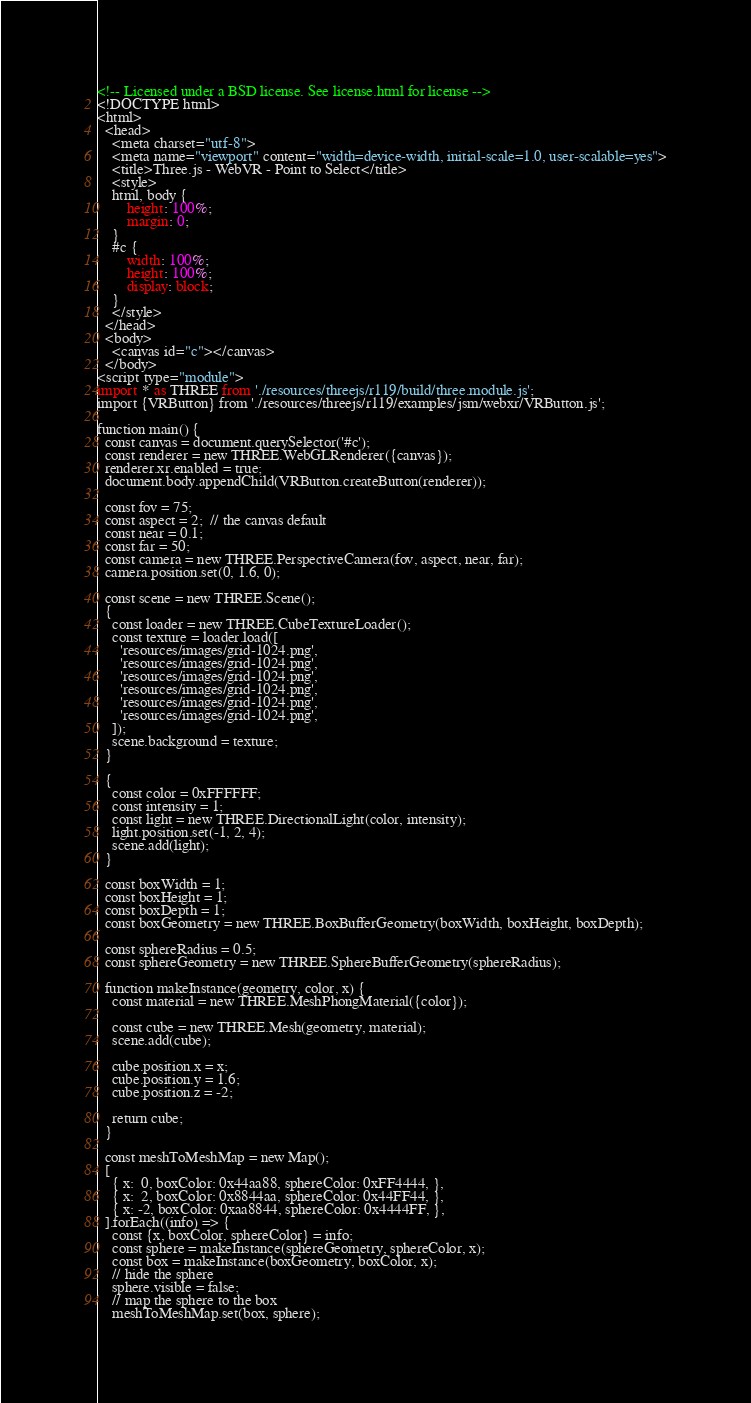<code> <loc_0><loc_0><loc_500><loc_500><_HTML_><!-- Licensed under a BSD license. See license.html for license -->
<!DOCTYPE html>
<html>
  <head>
    <meta charset="utf-8">
    <meta name="viewport" content="width=device-width, initial-scale=1.0, user-scalable=yes">
    <title>Three.js - WebVR - Point to Select</title>
    <style>
    html, body {
        height: 100%;
        margin: 0;
    }
    #c {
        width: 100%;
        height: 100%;
        display: block;
    }
    </style>
  </head>
  <body>
    <canvas id="c"></canvas>
  </body>
<script type="module">
import * as THREE from './resources/threejs/r119/build/three.module.js';
import {VRButton} from './resources/threejs/r119/examples/jsm/webxr/VRButton.js';

function main() {
  const canvas = document.querySelector('#c');
  const renderer = new THREE.WebGLRenderer({canvas});
  renderer.xr.enabled = true;
  document.body.appendChild(VRButton.createButton(renderer));

  const fov = 75;
  const aspect = 2;  // the canvas default
  const near = 0.1;
  const far = 50;
  const camera = new THREE.PerspectiveCamera(fov, aspect, near, far);
  camera.position.set(0, 1.6, 0);

  const scene = new THREE.Scene();
  {
    const loader = new THREE.CubeTextureLoader();
    const texture = loader.load([
      'resources/images/grid-1024.png',
      'resources/images/grid-1024.png',
      'resources/images/grid-1024.png',
      'resources/images/grid-1024.png',
      'resources/images/grid-1024.png',
      'resources/images/grid-1024.png',
    ]);
    scene.background = texture;
  }

  {
    const color = 0xFFFFFF;
    const intensity = 1;
    const light = new THREE.DirectionalLight(color, intensity);
    light.position.set(-1, 2, 4);
    scene.add(light);
  }

  const boxWidth = 1;
  const boxHeight = 1;
  const boxDepth = 1;
  const boxGeometry = new THREE.BoxBufferGeometry(boxWidth, boxHeight, boxDepth);

  const sphereRadius = 0.5;
  const sphereGeometry = new THREE.SphereBufferGeometry(sphereRadius);

  function makeInstance(geometry, color, x) {
    const material = new THREE.MeshPhongMaterial({color});

    const cube = new THREE.Mesh(geometry, material);
    scene.add(cube);

    cube.position.x = x;
    cube.position.y = 1.6;
    cube.position.z = -2;

    return cube;
  }

  const meshToMeshMap = new Map();
  [
    { x:  0, boxColor: 0x44aa88, sphereColor: 0xFF4444, },
    { x:  2, boxColor: 0x8844aa, sphereColor: 0x44FF44, },
    { x: -2, boxColor: 0xaa8844, sphereColor: 0x4444FF, },
  ].forEach((info) => {
    const {x, boxColor, sphereColor} = info;
    const sphere = makeInstance(sphereGeometry, sphereColor, x);
    const box = makeInstance(boxGeometry, boxColor, x);
    // hide the sphere
    sphere.visible = false;
    // map the sphere to the box
    meshToMeshMap.set(box, sphere);</code> 